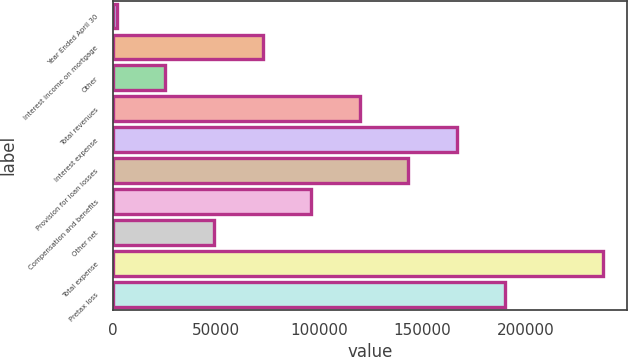<chart> <loc_0><loc_0><loc_500><loc_500><bar_chart><fcel>Year Ended April 30<fcel>Interest income on mortgage<fcel>Other<fcel>Total revenues<fcel>Interest expense<fcel>Provision for loan losses<fcel>Compensation and benefits<fcel>Other net<fcel>Total expense<fcel>Pretax loss<nl><fcel>2009<fcel>72646.1<fcel>25554.7<fcel>119738<fcel>166829<fcel>143283<fcel>96191.8<fcel>49100.4<fcel>237466<fcel>190375<nl></chart> 